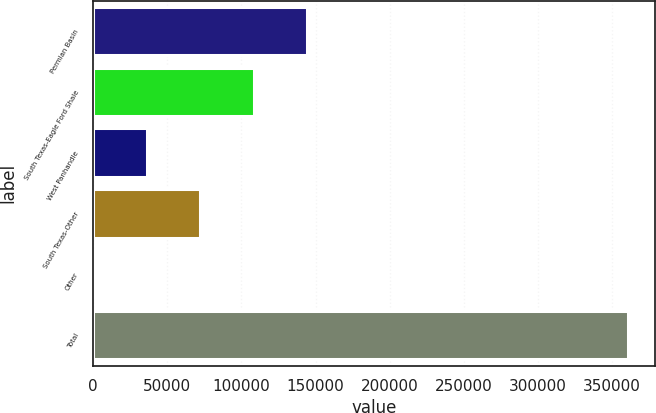Convert chart to OTSL. <chart><loc_0><loc_0><loc_500><loc_500><bar_chart><fcel>Permian Basin<fcel>South Texas-Eagle Ford Shale<fcel>West Panhandle<fcel>South Texas-Other<fcel>Other<fcel>Total<nl><fcel>144318<fcel>108261<fcel>36146.3<fcel>72203.6<fcel>89<fcel>360662<nl></chart> 